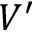<formula> <loc_0><loc_0><loc_500><loc_500>V ^ { \prime }</formula> 